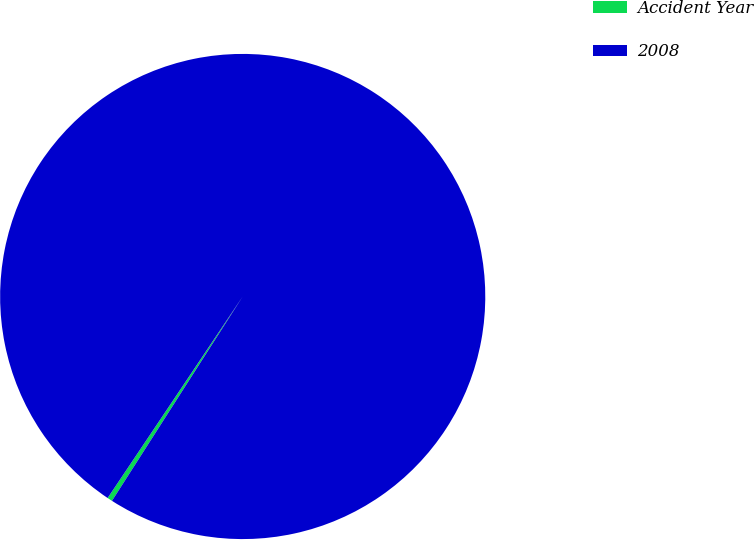Convert chart. <chart><loc_0><loc_0><loc_500><loc_500><pie_chart><fcel>Accident Year<fcel>2008<nl><fcel>0.34%<fcel>99.66%<nl></chart> 